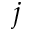<formula> <loc_0><loc_0><loc_500><loc_500>j</formula> 